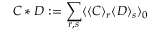Convert formula to latex. <formula><loc_0><loc_0><loc_500><loc_500>C * D \colon = \sum _ { r , s } \langle \langle C \rangle _ { r } \langle D \rangle _ { s } \rangle _ { 0 }</formula> 